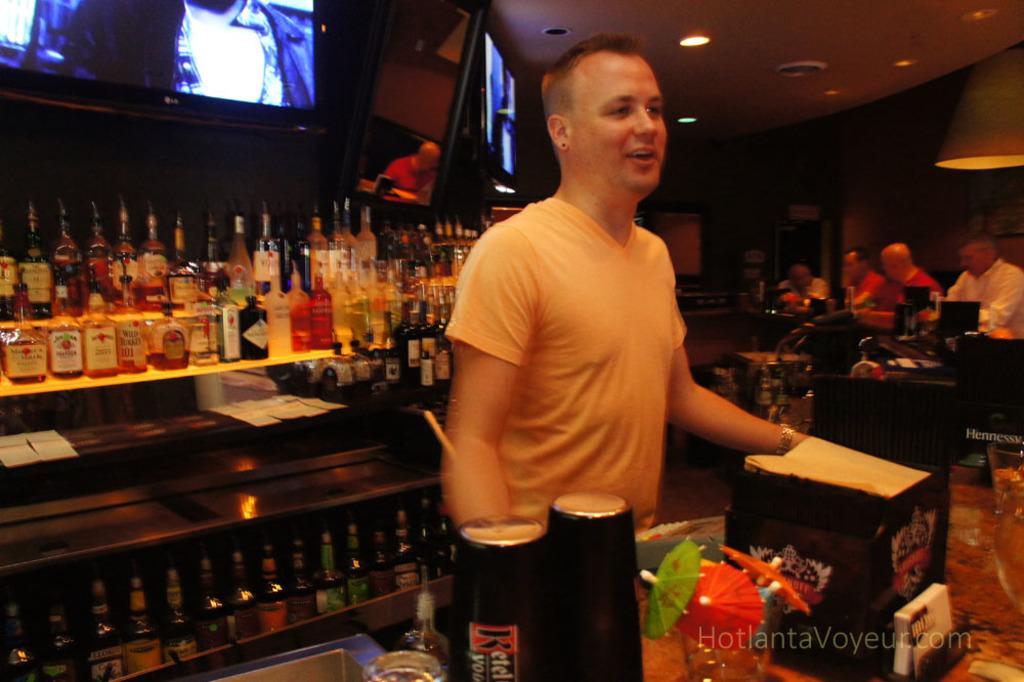What is one of the brands of alcohol behind the bartender?
Offer a terse response. Jim beam. 